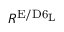Convert formula to latex. <formula><loc_0><loc_0><loc_500><loc_500>R ^ { E / D 6 _ { L } }</formula> 